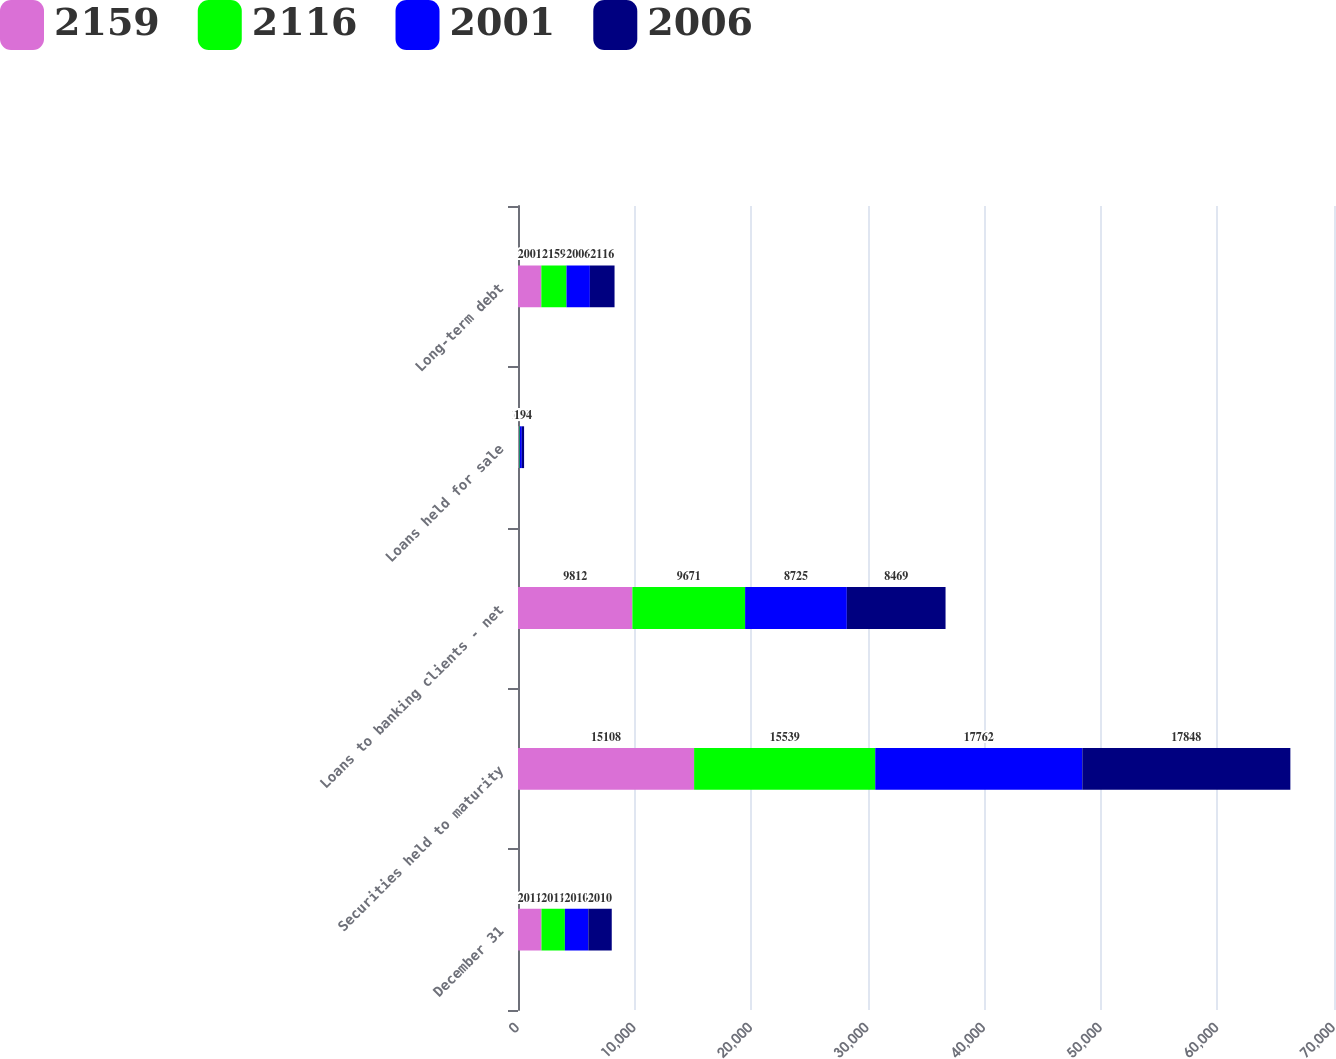Convert chart. <chart><loc_0><loc_0><loc_500><loc_500><stacked_bar_chart><ecel><fcel>December 31<fcel>Securities held to maturity<fcel>Loans to banking clients - net<fcel>Loans held for sale<fcel>Long-term debt<nl><fcel>2159<fcel>2011<fcel>15108<fcel>9812<fcel>70<fcel>2001<nl><fcel>2116<fcel>2011<fcel>15539<fcel>9671<fcel>73<fcel>2159<nl><fcel>2001<fcel>2010<fcel>17762<fcel>8725<fcel>185<fcel>2006<nl><fcel>2006<fcel>2010<fcel>17848<fcel>8469<fcel>194<fcel>2116<nl></chart> 